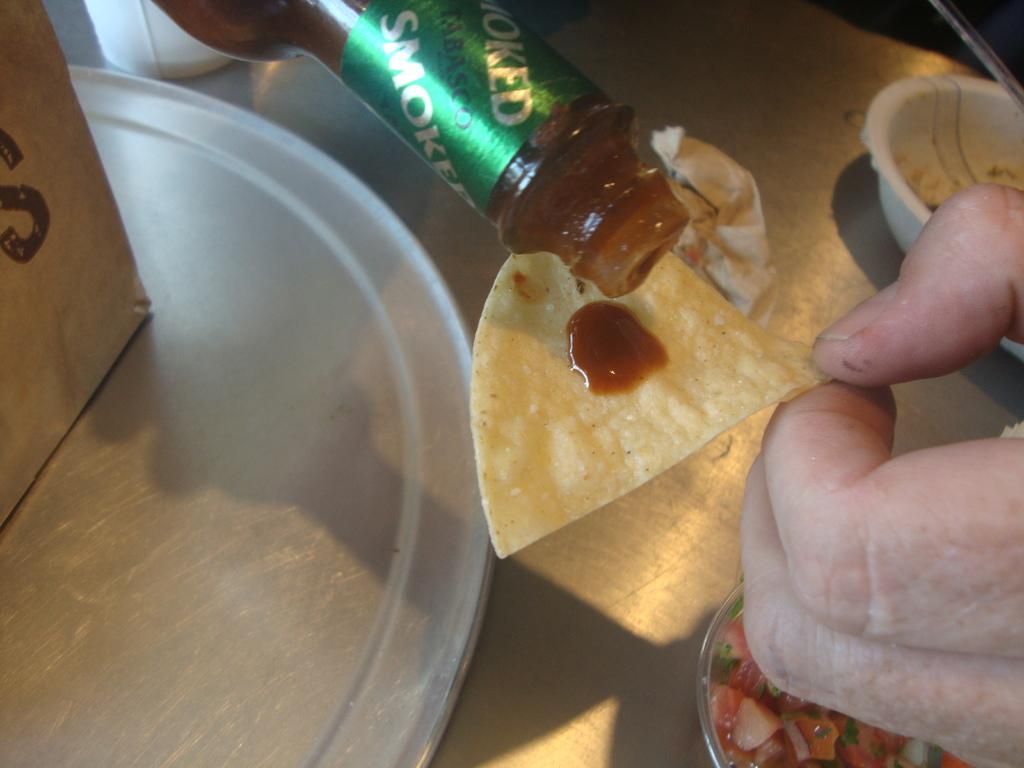<image>
Write a terse but informative summary of the picture. Person putting some smoked tobasco on a chip. 